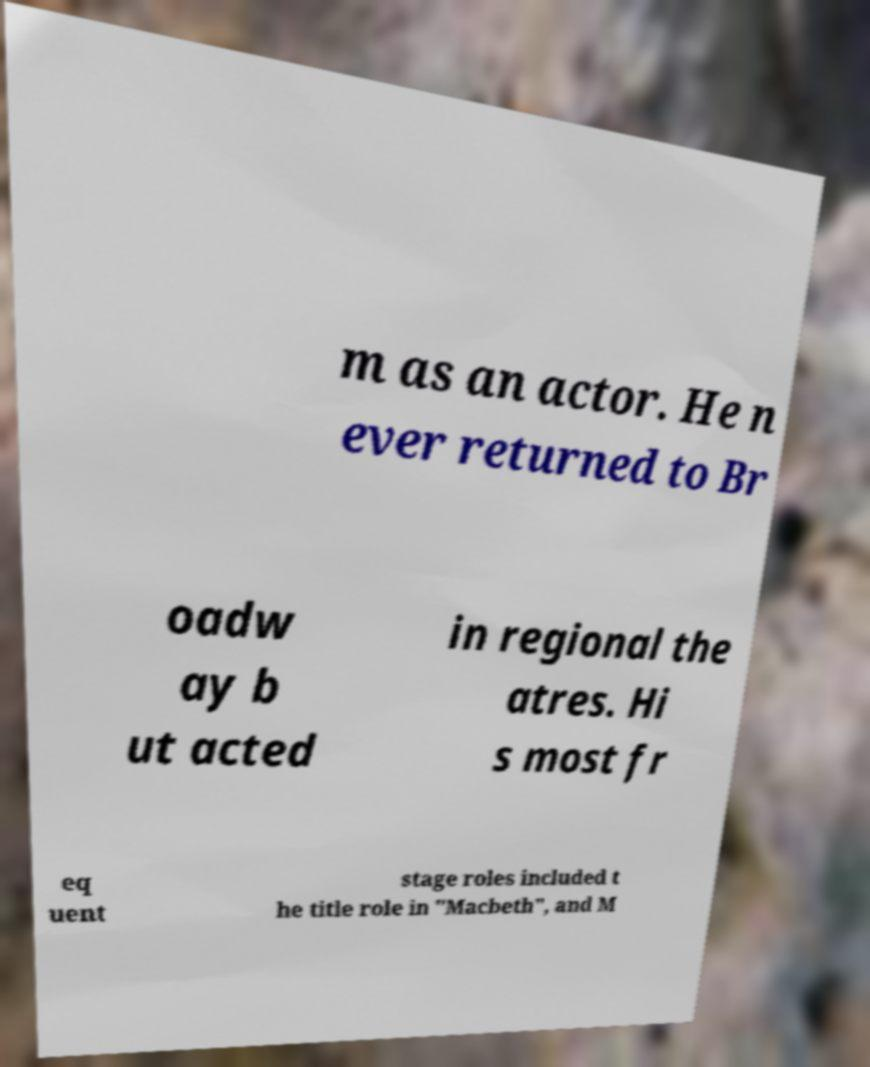Please identify and transcribe the text found in this image. m as an actor. He n ever returned to Br oadw ay b ut acted in regional the atres. Hi s most fr eq uent stage roles included t he title role in "Macbeth", and M 